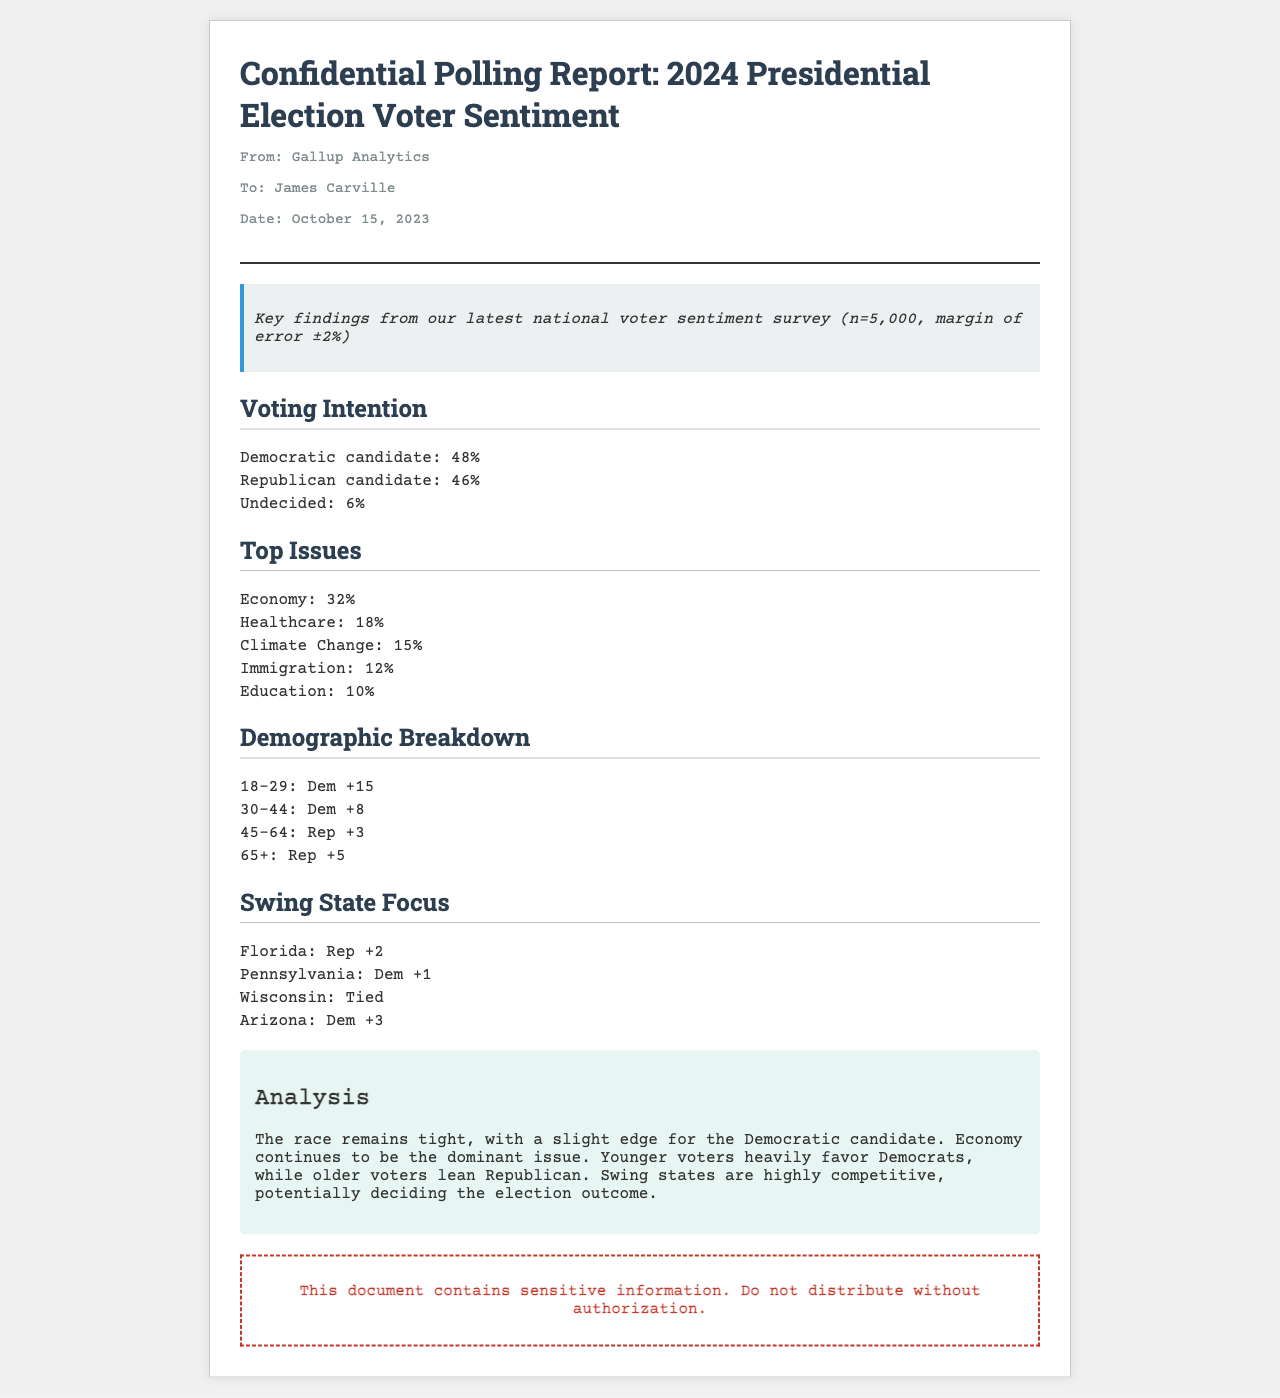What is the date of the report? The report was dated October 15, 2023, as stated in the meta-info section.
Answer: October 15, 2023 Who is the sender of the report? The report is from Gallup Analytics, which is mentioned in the header.
Answer: Gallup Analytics What is the margin of error for the survey? The margin of error is stated as ±2% in the summary.
Answer: ±2% What percentage of voters are undecided? The document states that 6% of voters are undecided under the Voting Intention section.
Answer: 6% Which issue has the highest percentage among voters? The Economy has the highest percentage at 32%, based on the Top Issues section.
Answer: Economy: 32% How do voters aged 18-29 lean in terms of party preference? The demographic breakdown shows that voters aged 18-29 lean Democratic by +15.
Answer: Dem +15 Which swing state shows a deadlock in voter preference? Wisconsin is noted as being tied according to the Swing State Focus section.
Answer: Tied What candidate has a slight edge according to the report? The Democratic candidate appears to have a slight edge as mentioned in the Analysis section.
Answer: Democratic candidate What is the total sample size of the survey? The sample size of the survey is noted as n=5,000 in the summary.
Answer: n=5,000 